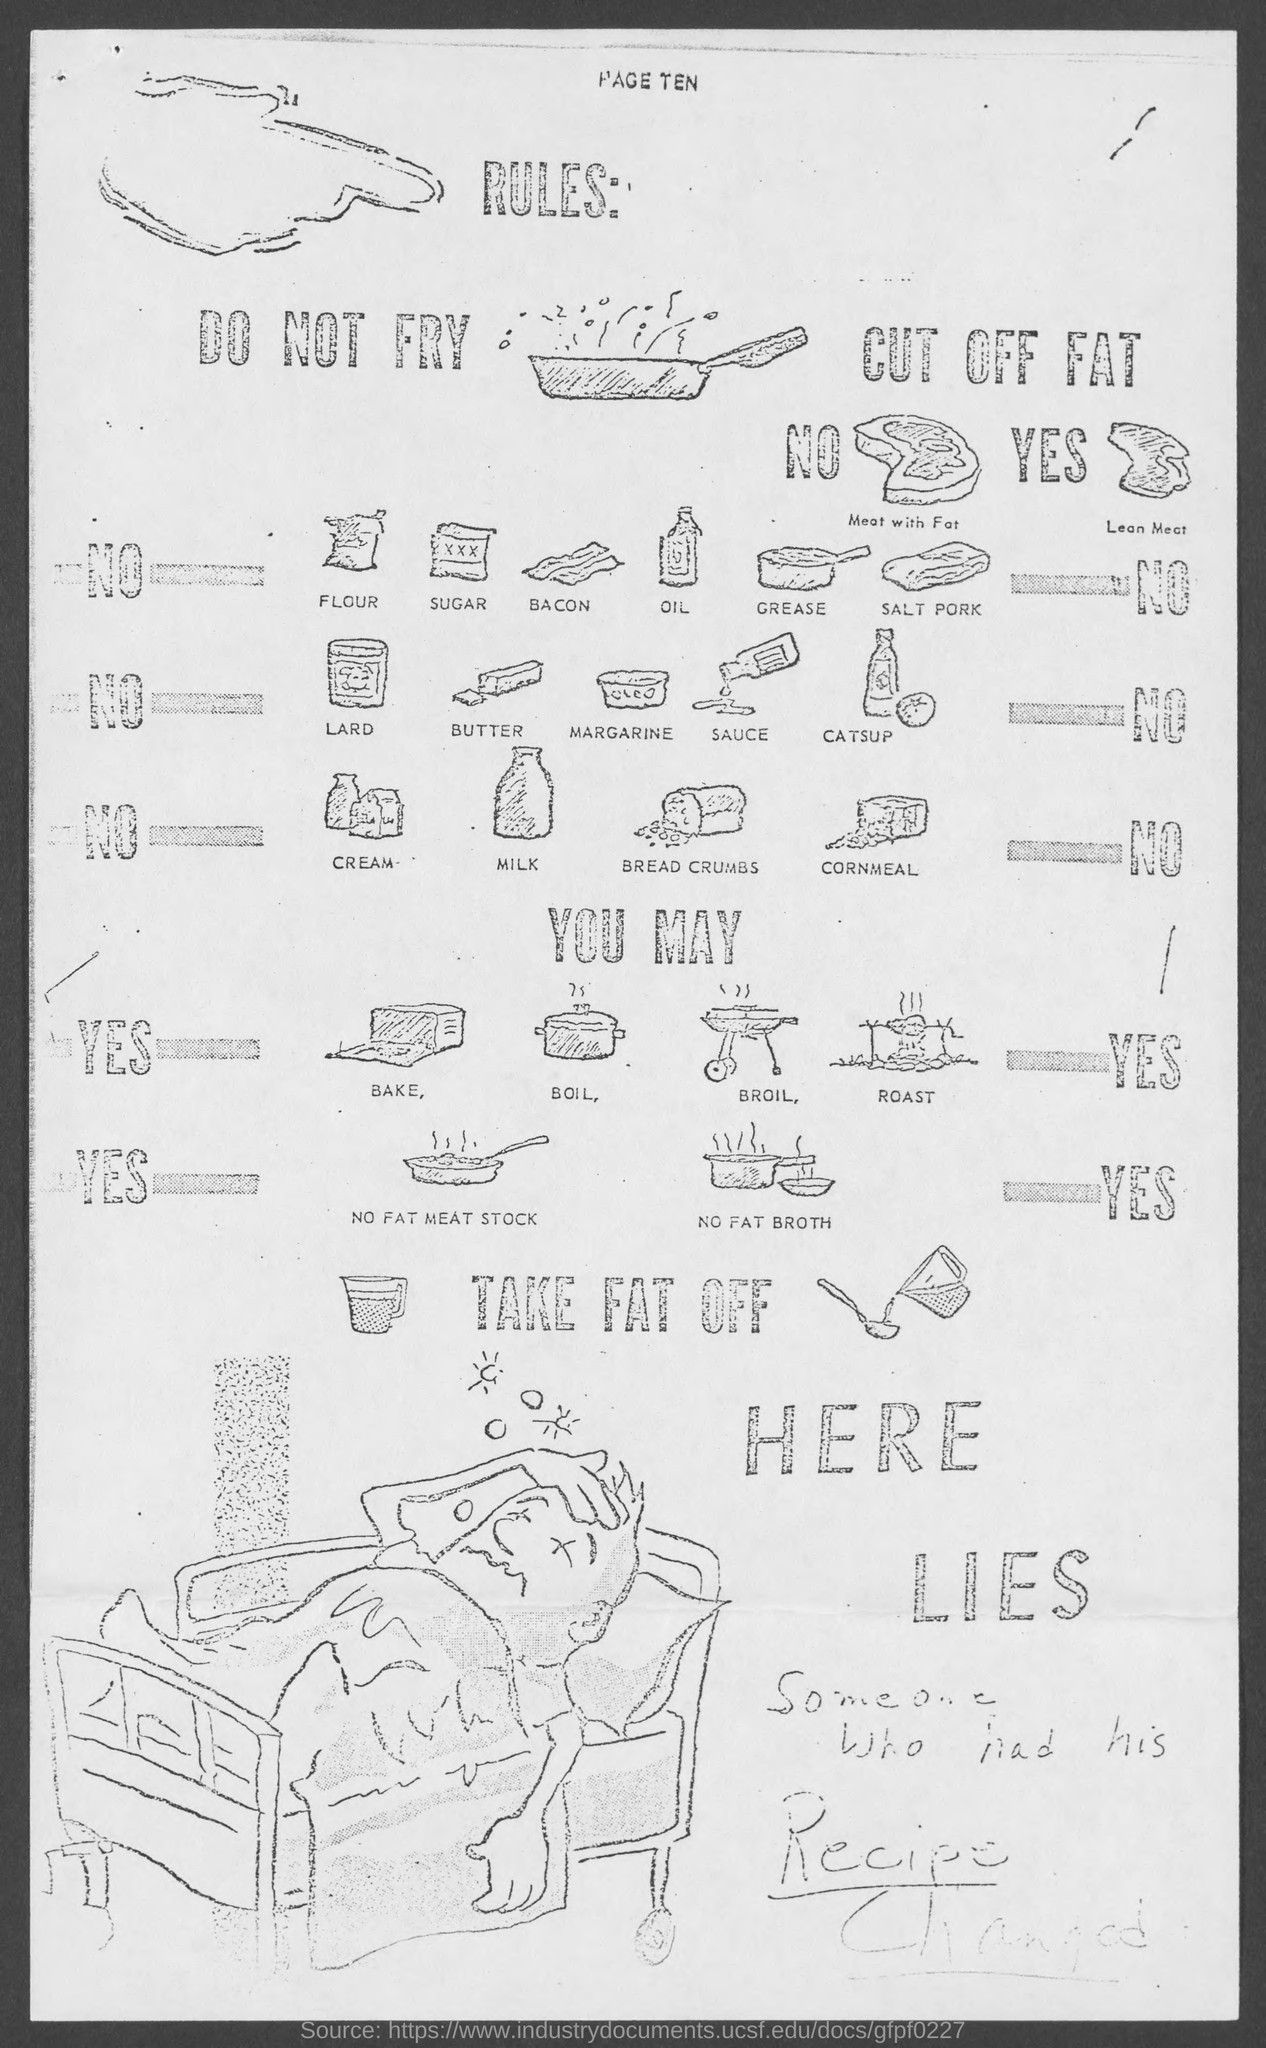Highlight a few significant elements in this photo. The page number mentioned in this document is ten. 